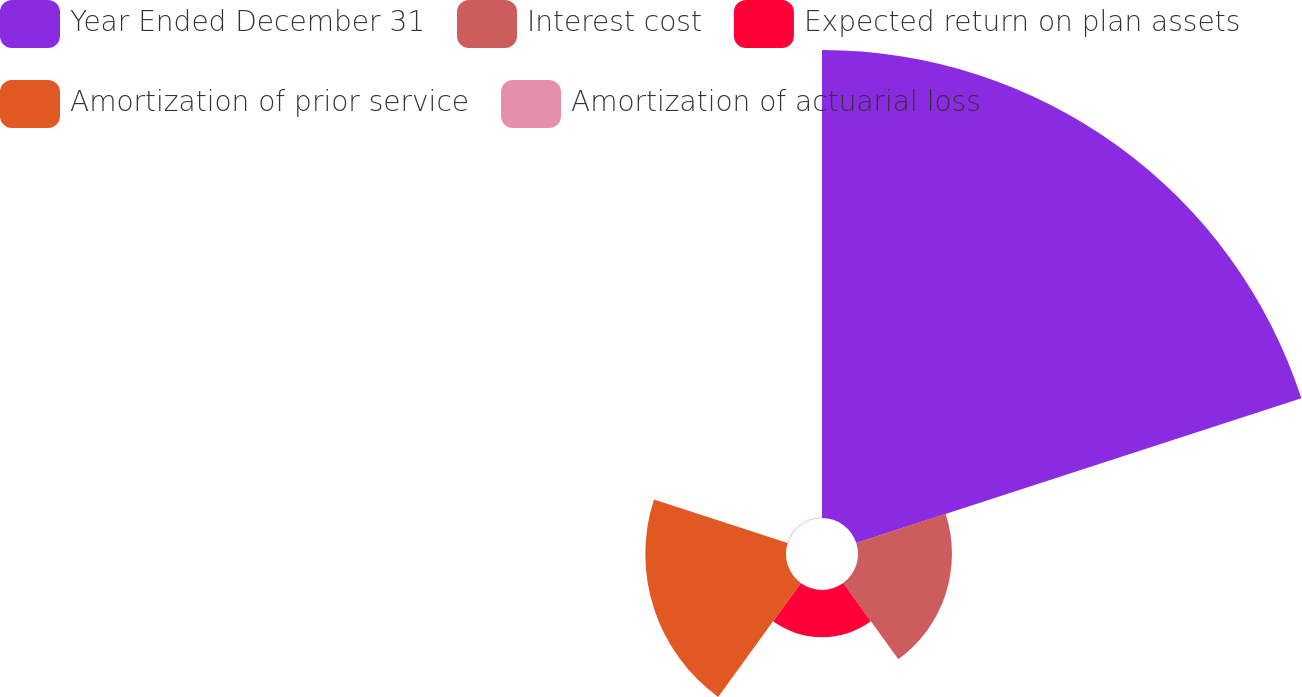<chart> <loc_0><loc_0><loc_500><loc_500><pie_chart><fcel>Year Ended December 31<fcel>Interest cost<fcel>Expected return on plan assets<fcel>Amortization of prior service<fcel>Amortization of actuarial loss<nl><fcel>62.37%<fcel>12.52%<fcel>6.29%<fcel>18.75%<fcel>0.06%<nl></chart> 